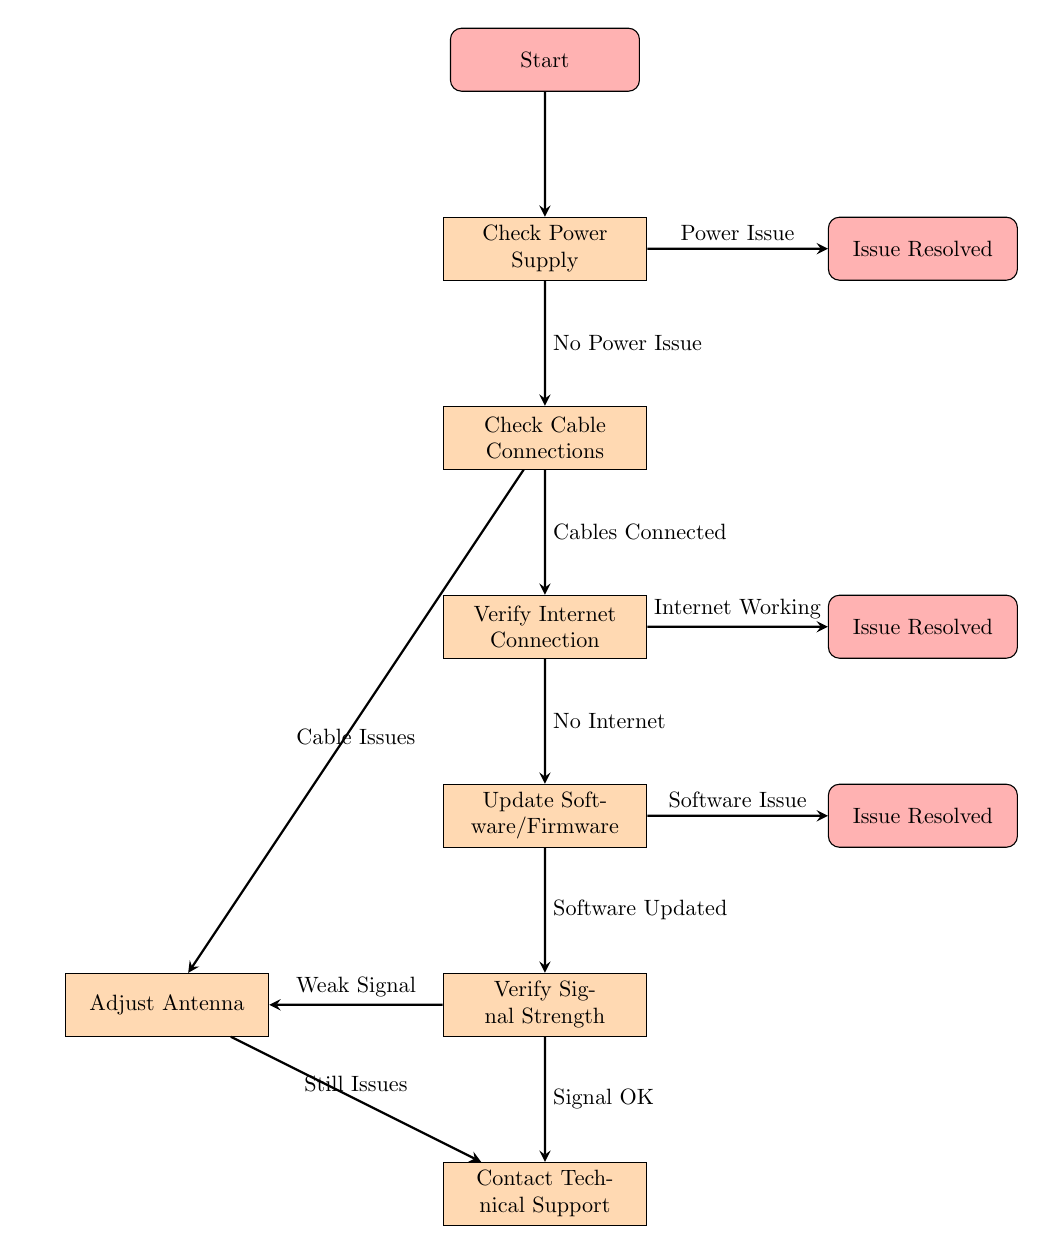What is the first action to take according to the flowchart? The flowchart starts with the "Start" node, which leads to the "Check Power Supply" node as the first action to be taken.
Answer: Check Power Supply How many major steps are there in the troubleshooting process? The troubleshooting process consists of five major steps: Check Power Supply, Check Cable Connections, Verify Internet Connection, Update Software/Firmware, and Verify Signal Strength.
Answer: Five What do you do if there is a power issue? If there is a power issue, the next step indicated in the flowchart is to resolve the issue, which leads to the "Issue Resolved" node.
Answer: Issue Resolved If cable issues are detected, where does the flow lead next? The flow leads to the "Adjust Antenna" node after indicating that cable issues are present.
Answer: Adjust Antenna What action follows after verifying a weak signal? After verifying a weak signal, the next action indicated in the flowchart is to "Adjust Antenna."
Answer: Adjust Antenna What is the outcome if the software is updated successfully? If the software is updated successfully, the flowchart directs to the "Check Signal Strength" node, indicating the next step in the process.
Answer: Check Signal Strength What happens if the internet connection is verified as working? If the internet connection is verified as working, the flow leads directly to the "Issue Resolved" node, indicating no further actions are needed for this issue.
Answer: Issue Resolved What action should be taken if the signal is okay? If the signal is okay, the process directs to "Contact Technical Support" for further assistance.
Answer: Contact Technical Support How does the process conclude for any unresolved issues? The process concludes for unresolved issues by directing all paths towards "Contact Technical Support," indicating that further help is needed.
Answer: Contact Technical Support 